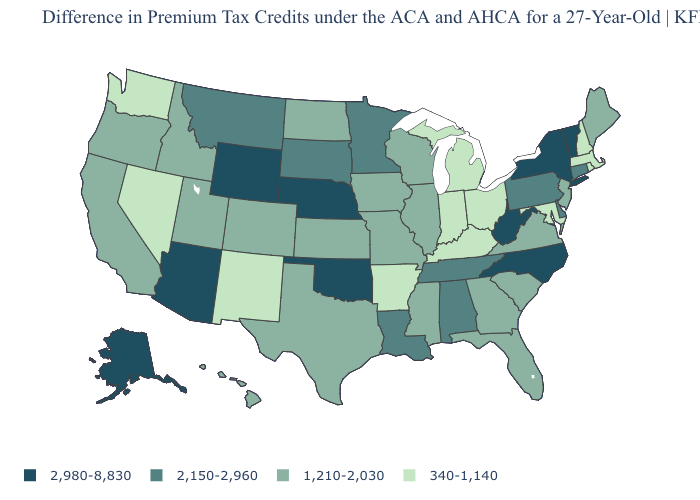What is the value of Louisiana?
Give a very brief answer. 2,150-2,960. Name the states that have a value in the range 2,150-2,960?
Keep it brief. Alabama, Connecticut, Delaware, Louisiana, Minnesota, Montana, Pennsylvania, South Dakota, Tennessee. What is the lowest value in the USA?
Quick response, please. 340-1,140. What is the value of Wisconsin?
Keep it brief. 1,210-2,030. What is the value of Rhode Island?
Answer briefly. 340-1,140. What is the value of Alaska?
Quick response, please. 2,980-8,830. Does the map have missing data?
Quick response, please. No. Does West Virginia have the highest value in the South?
Short answer required. Yes. Which states have the lowest value in the South?
Quick response, please. Arkansas, Kentucky, Maryland. Does Alaska have the highest value in the USA?
Keep it brief. Yes. What is the highest value in the USA?
Quick response, please. 2,980-8,830. Is the legend a continuous bar?
Give a very brief answer. No. Name the states that have a value in the range 2,980-8,830?
Answer briefly. Alaska, Arizona, Nebraska, New York, North Carolina, Oklahoma, Vermont, West Virginia, Wyoming. How many symbols are there in the legend?
Be succinct. 4. Does Alaska have the same value as West Virginia?
Short answer required. Yes. 